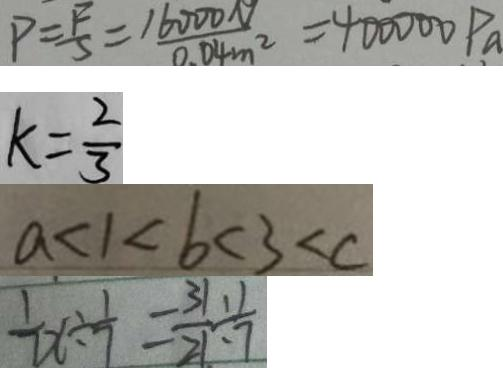Convert formula to latex. <formula><loc_0><loc_0><loc_500><loc_500>P = \frac { F } { S } = \frac { 1 6 0 0 0 N } { 0 . 0 4 m ^ { 2 } } = 4 0 0 0 0 0 P a 
 k = \frac { 2 } { 3 } 
 a < 1 < b < 3 < c 
 \frac { 1 } { 7 } x \div \frac { 1 } { 7 } = \frac { 3 1 } { 2 1 } \div \frac { 1 } { 7 }</formula> 